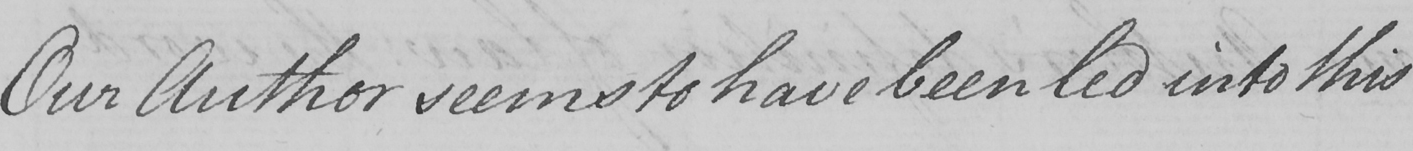What is written in this line of handwriting? Our Author seems to have been led into this 